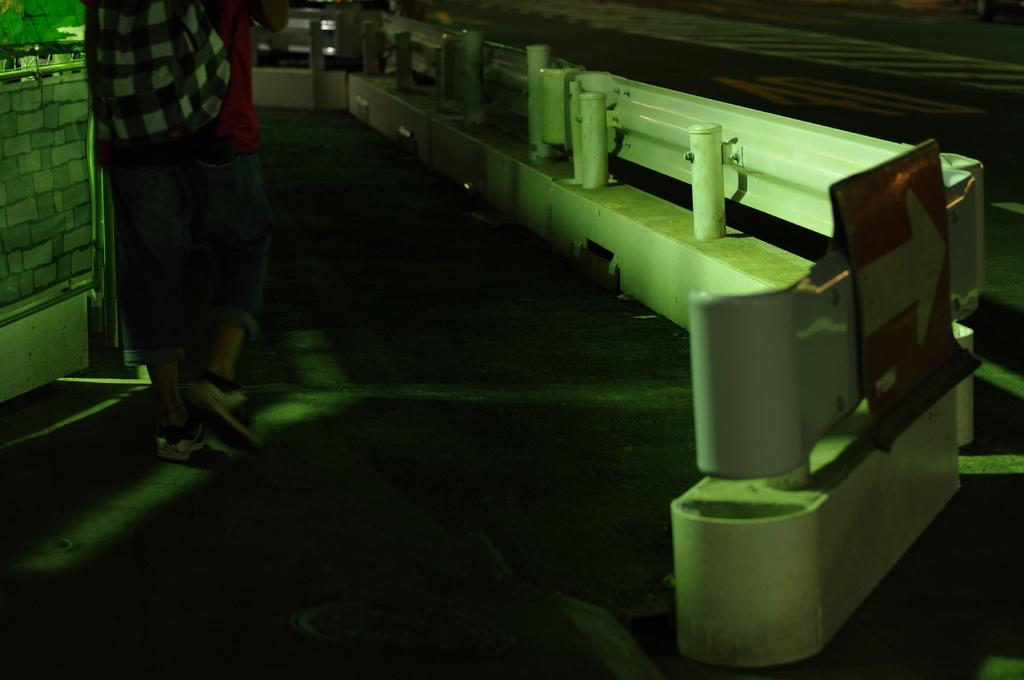What is the main feature of the image? There is a road in the image. What type of surface can be seen in the image? There is an iron surface in the image. Can you describe the person in the image? There is a person standing on the left side of the image. What type of fiction is the person reading in the image? There is no indication in the image that the person is reading any fiction, as the person's activity is not described. 